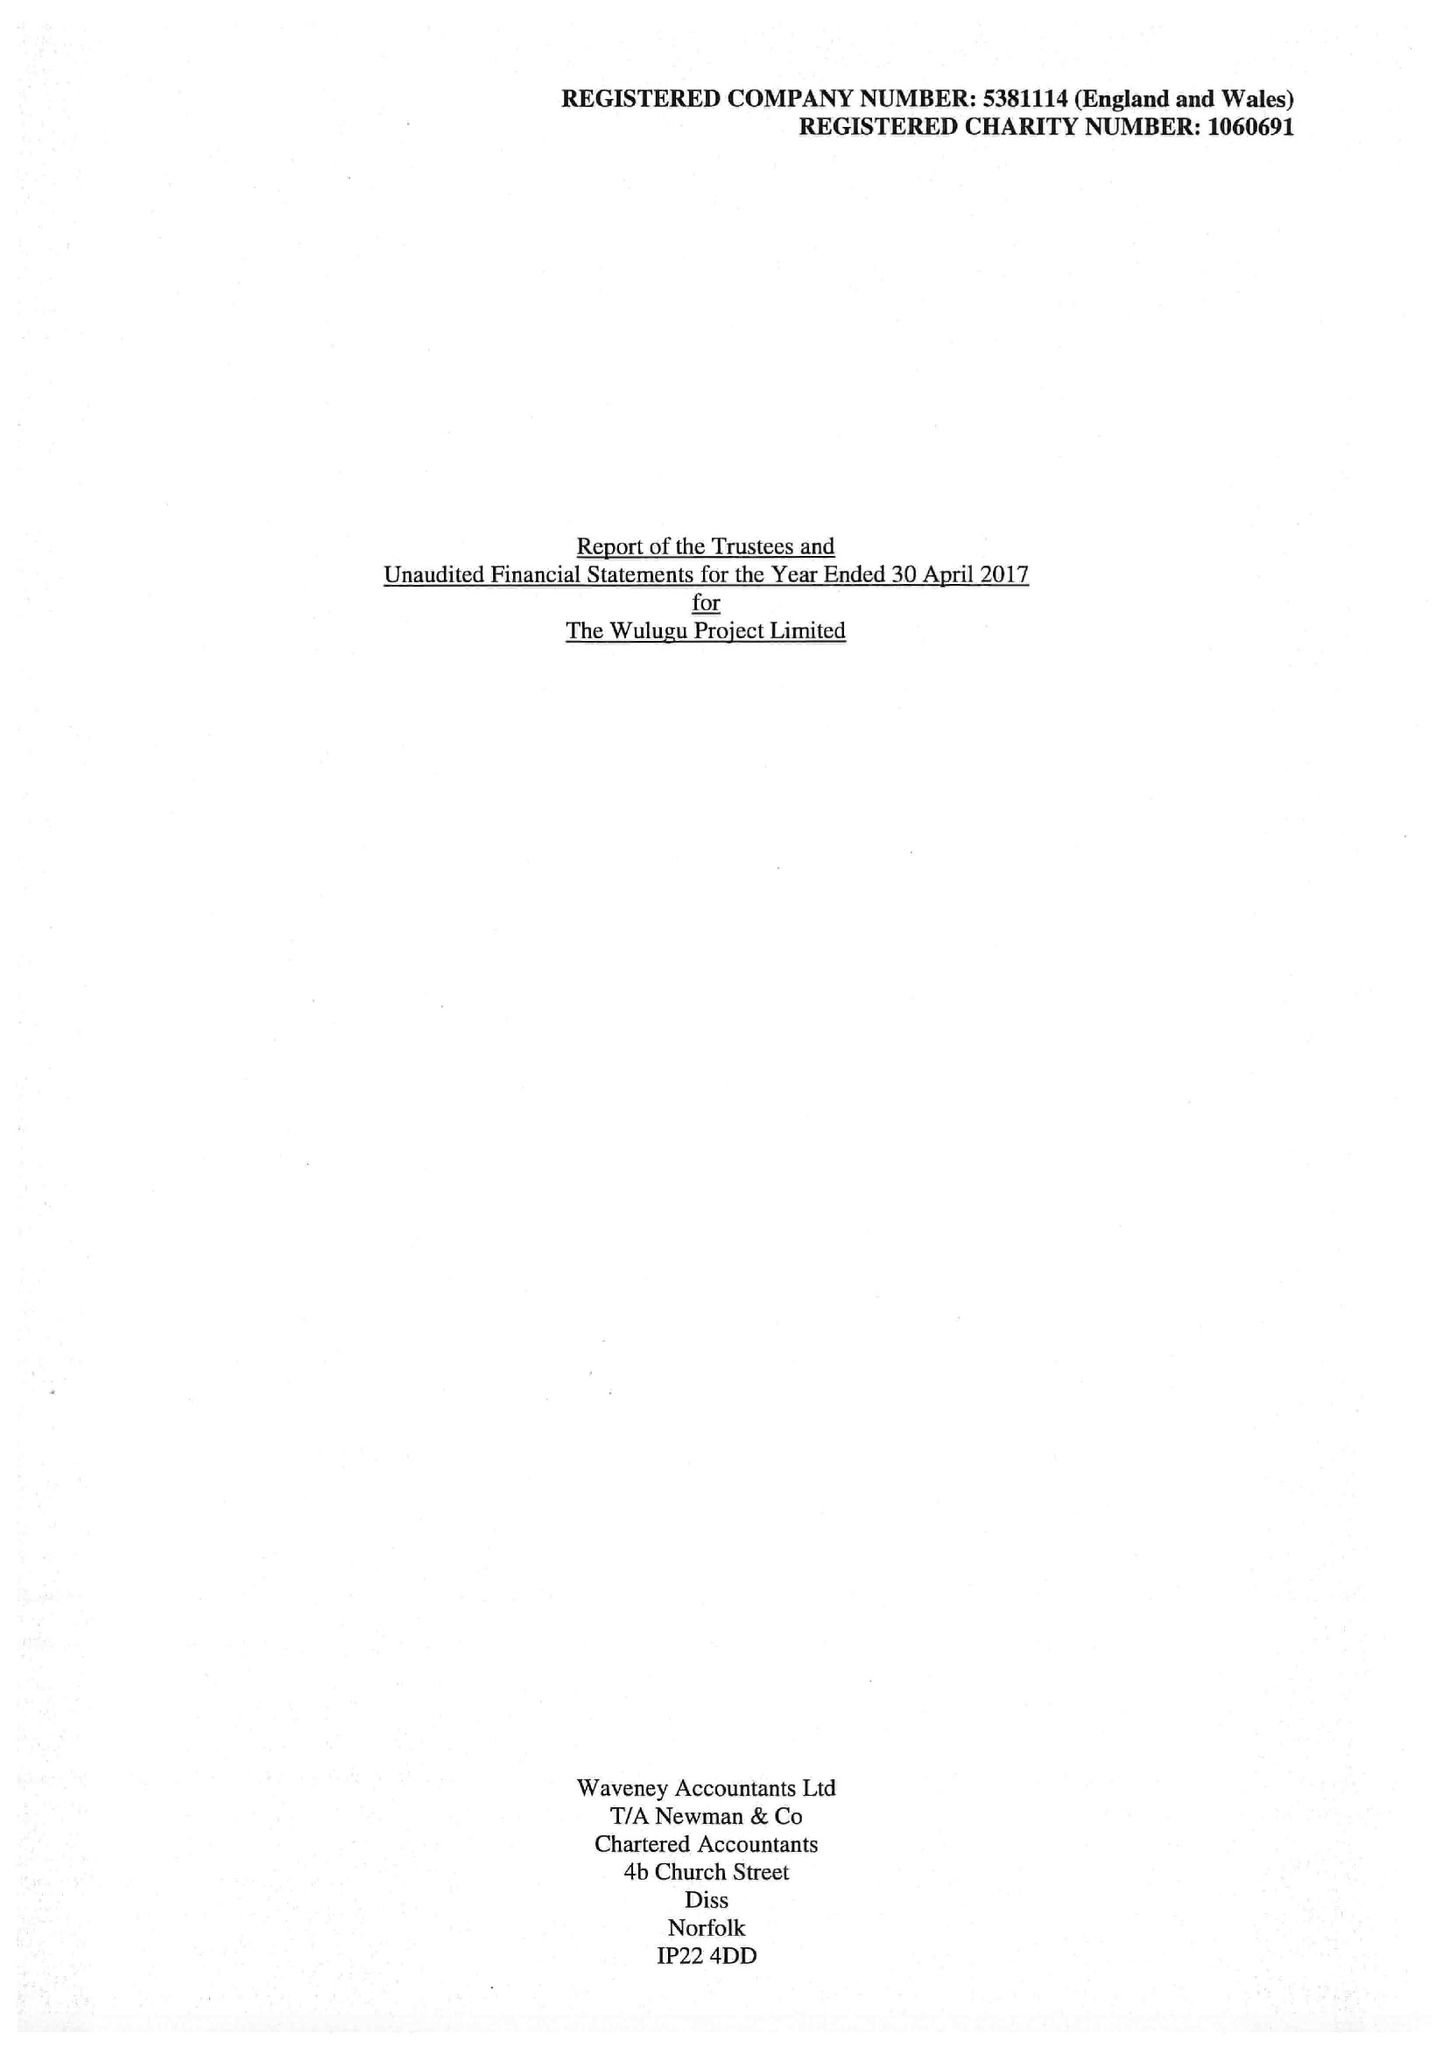What is the value for the charity_number?
Answer the question using a single word or phrase. 1060691 